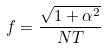Convert formula to latex. <formula><loc_0><loc_0><loc_500><loc_500>f = \frac { \sqrt { 1 + \alpha ^ { 2 } } } { N T }</formula> 